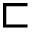Convert formula to latex. <formula><loc_0><loc_0><loc_500><loc_500>\sqsubset</formula> 